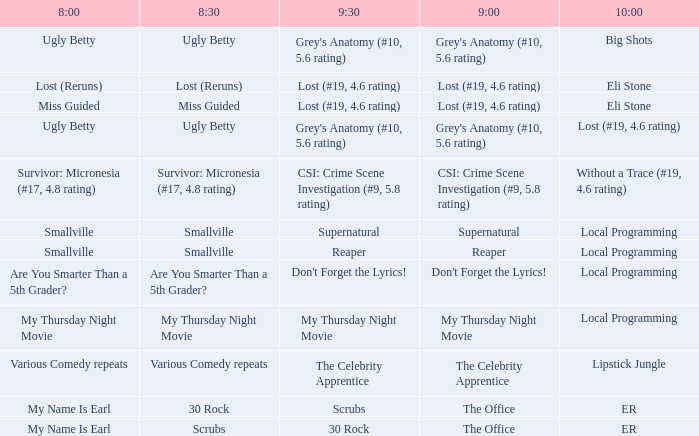What is at 10:00 when at 9:00 it is lost (#19, 4.6 rating) and at 8:30 it is lost (reruns)? Eli Stone. 